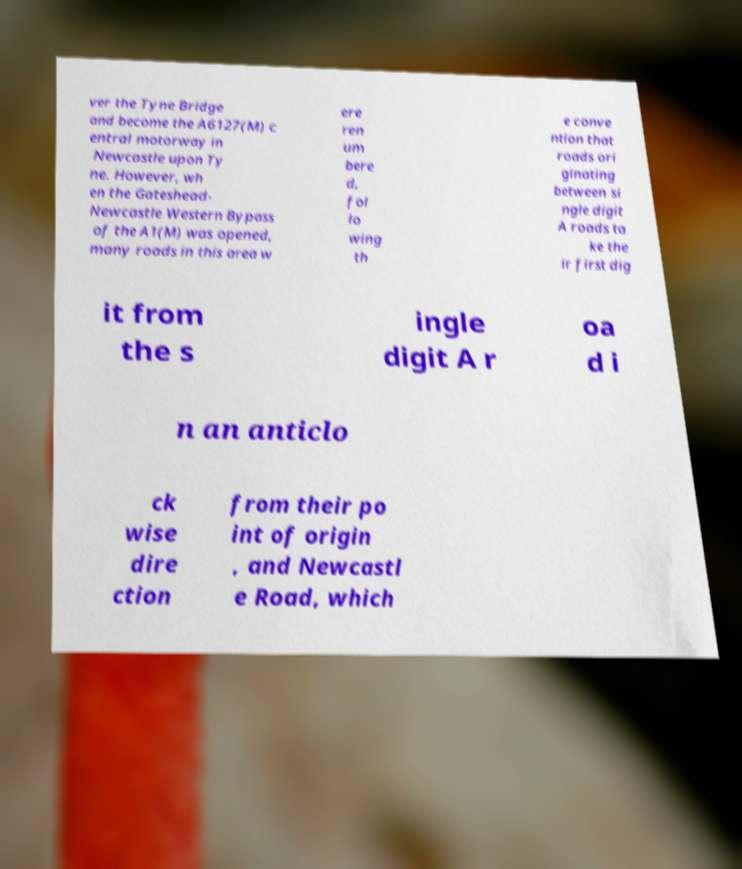What messages or text are displayed in this image? I need them in a readable, typed format. ver the Tyne Bridge and become the A6127(M) c entral motorway in Newcastle upon Ty ne. However, wh en the Gateshead- Newcastle Western Bypass of the A1(M) was opened, many roads in this area w ere ren um bere d, fol lo wing th e conve ntion that roads ori ginating between si ngle digit A roads ta ke the ir first dig it from the s ingle digit A r oa d i n an anticlo ck wise dire ction from their po int of origin , and Newcastl e Road, which 